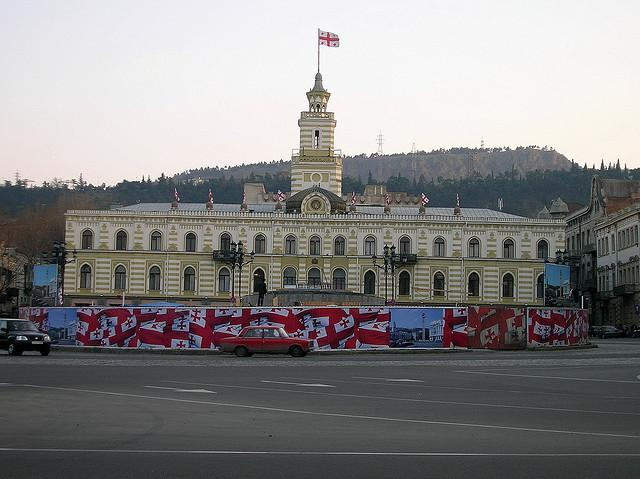This country has what type of government? communist 